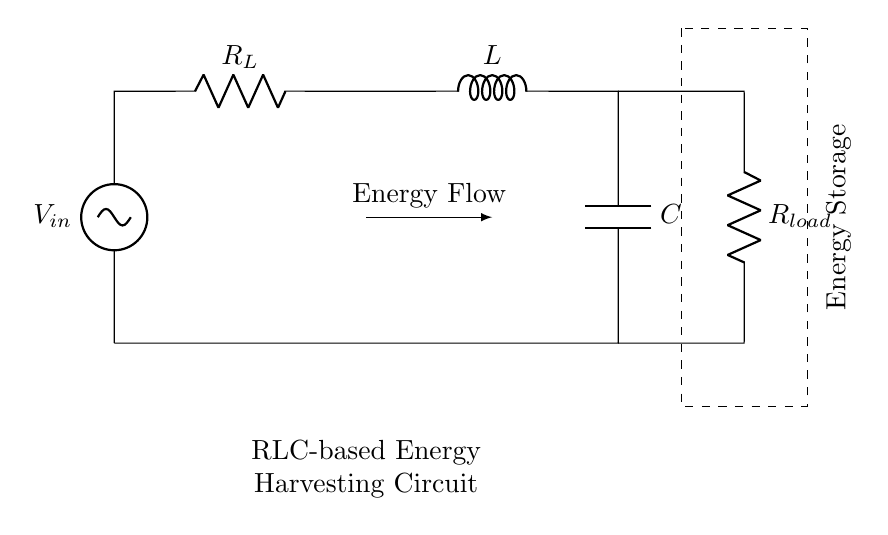What is the input voltage in the circuit? The input voltage is indicated by \( V_{in} \) at the top left of the circuit diagram. This component is marked as the voltage source.
Answer: \( V_{in} \) What type of component is \( R_L \)? \( R_L \) is labeled in the diagram as a resistor, representing a load resistor in this circuit. This can be deduced from the standard representation of resistors in circuit diagrams, which is a zigzag line.
Answer: Resistor What is the function of the inductor in this circuit? The inductor \( L \) is used to store energy in a magnetic field when current flows through it. Inductors oppose changes in current, which is crucial for stabilizing the circuit operation during energy harvesting.
Answer: Energy storage How many energy storage elements are present in the circuit? The circuit has one energy storage component, which is the capacitor \( C \) connected in parallel with \( R_{load} \). The dashed rectangle indicates a storage area, suggesting a collective function for the inductor and capacitor.
Answer: Two (inductor and capacitor) What is the role of \( R_{load} \) in the circuit? \( R_{load} \) serves as the load resistor where the harvested energy is transferred for use, completing the circuit. The connection from the inductor and capacitor to this resistor indicates its function in the energy flow.
Answer: Load resistor What is the energy flow direction in this circuit? The energy flows from the voltage source through \( R_L \) to the inductor and capacitor and then to \( R_{load} \). The arrow labeled "Energy Flow" illustrates this direction, indicating the path of energy transfer.
Answer: From input through load to storage 